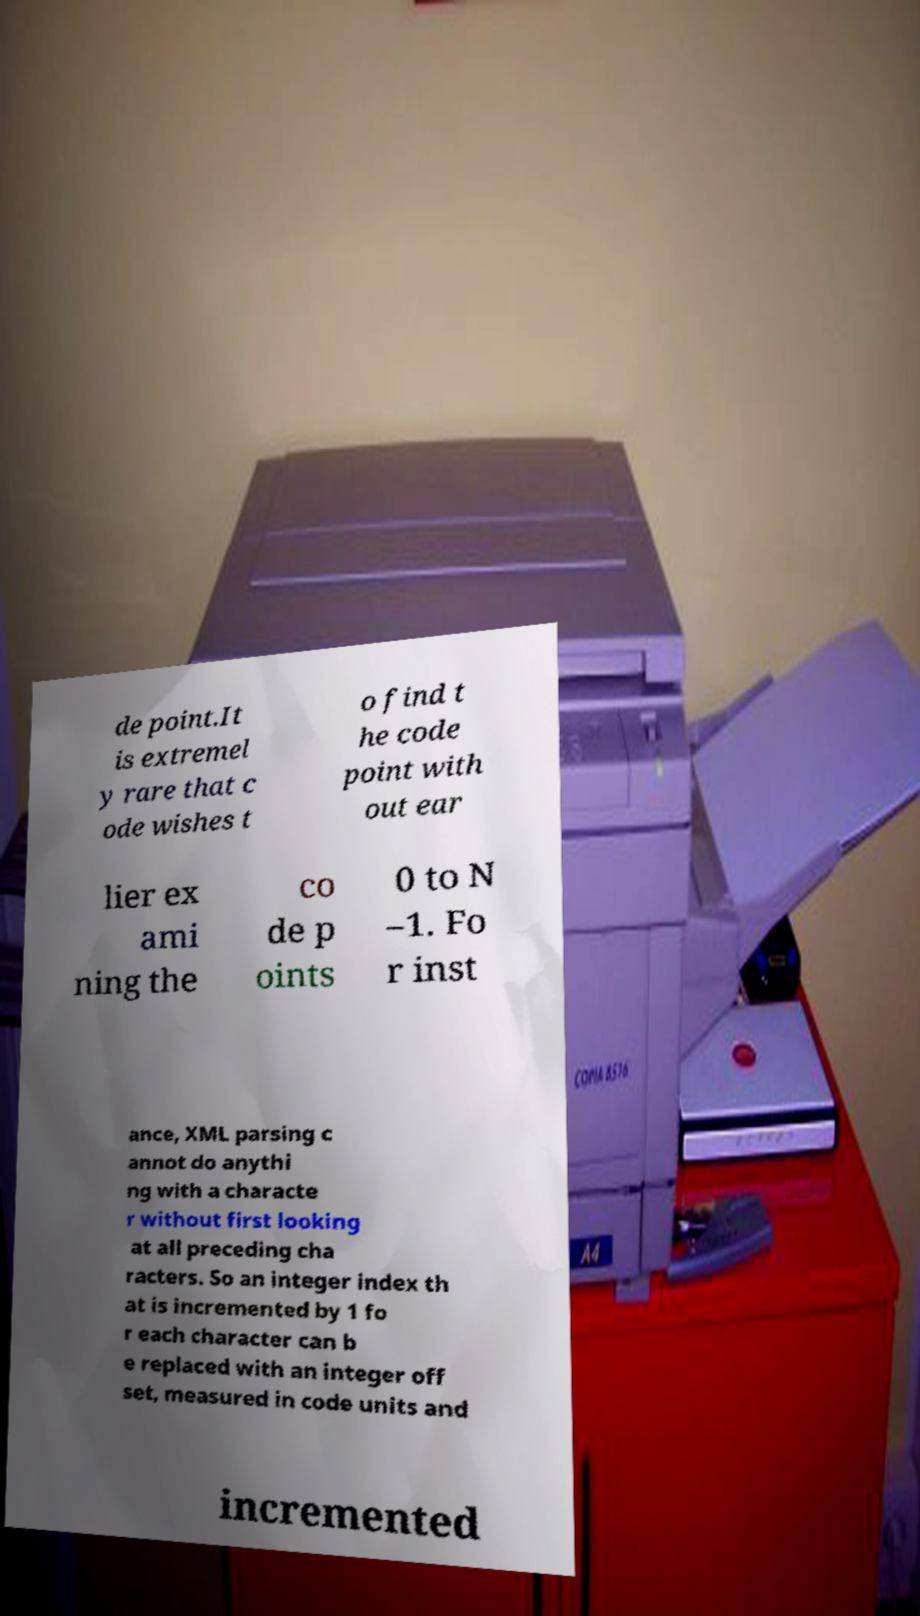Please read and relay the text visible in this image. What does it say? de point.It is extremel y rare that c ode wishes t o find t he code point with out ear lier ex ami ning the co de p oints 0 to N –1. Fo r inst ance, XML parsing c annot do anythi ng with a characte r without first looking at all preceding cha racters. So an integer index th at is incremented by 1 fo r each character can b e replaced with an integer off set, measured in code units and incremented 